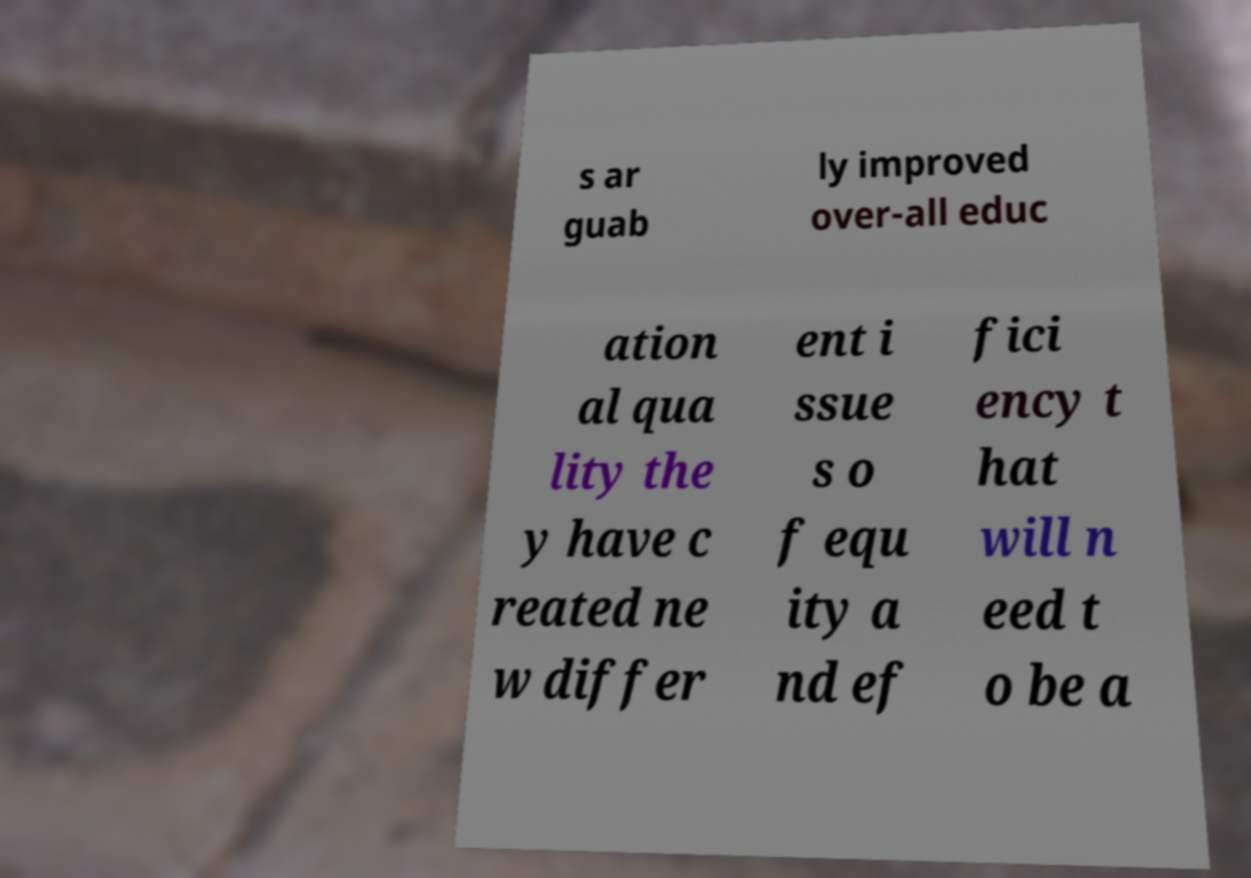Could you extract and type out the text from this image? s ar guab ly improved over-all educ ation al qua lity the y have c reated ne w differ ent i ssue s o f equ ity a nd ef fici ency t hat will n eed t o be a 